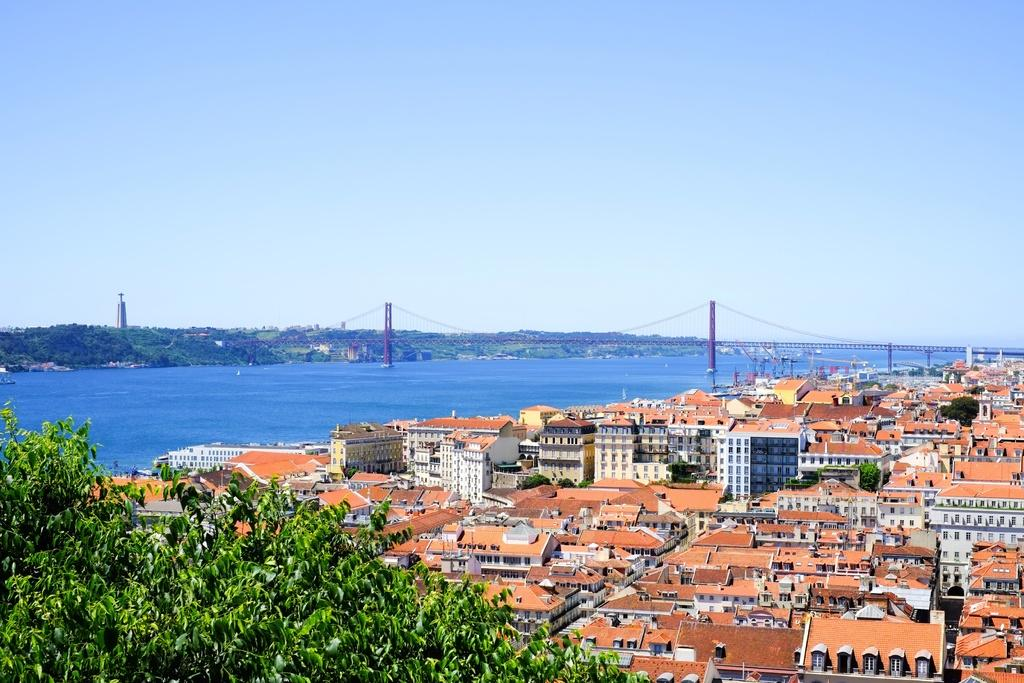What is located in the front of the image? There are leaves in the front of the image. What can be seen in the background of the image? There are buildings, a sea, a bridge, and trees visible in the background of the image. How many cakes are hanging from the bridge in the image? There are no cakes present in the image, and they are not hanging from the bridge. What is the plot of the story being told in the image? The image does not depict a story or plot; it is a visual representation of a scene. 